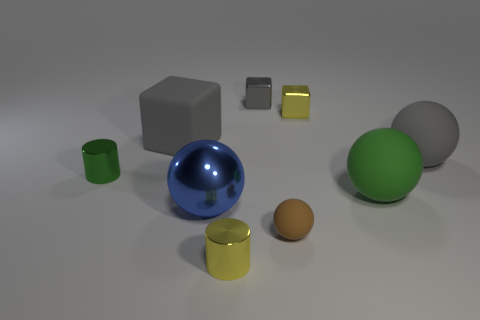How many things are either gray matte spheres or yellow cylinders?
Keep it short and to the point. 2. There is a rubber object that is the same size as the green metallic cylinder; what color is it?
Offer a terse response. Brown. What number of objects are either small shiny cylinders that are behind the brown object or rubber cylinders?
Provide a succinct answer. 1. How many other things are the same size as the green ball?
Provide a short and direct response. 3. There is a gray rubber object that is on the left side of the gray ball; how big is it?
Offer a very short reply. Large. What shape is the big green thing that is the same material as the tiny ball?
Offer a very short reply. Sphere. Is there any other thing of the same color as the metal ball?
Your answer should be compact. No. What is the color of the tiny thing that is to the left of the small yellow metallic thing in front of the big gray rubber ball?
Offer a terse response. Green. What number of small things are shiny cylinders or cyan cylinders?
Provide a succinct answer. 2. There is a small brown thing that is the same shape as the large blue thing; what is it made of?
Provide a short and direct response. Rubber. 